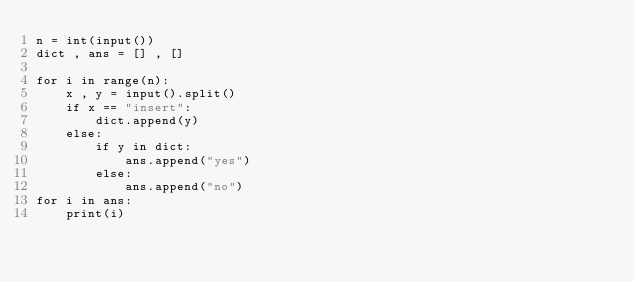<code> <loc_0><loc_0><loc_500><loc_500><_Python_>n = int(input())
dict , ans = [] , []

for i in range(n):
    x , y = input().split()
    if x == "insert":
        dict.append(y)
    else:
        if y in dict:
            ans.append("yes")
        else:
            ans.append("no")
for i in ans:
    print(i)</code> 